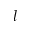<formula> <loc_0><loc_0><loc_500><loc_500>l</formula> 